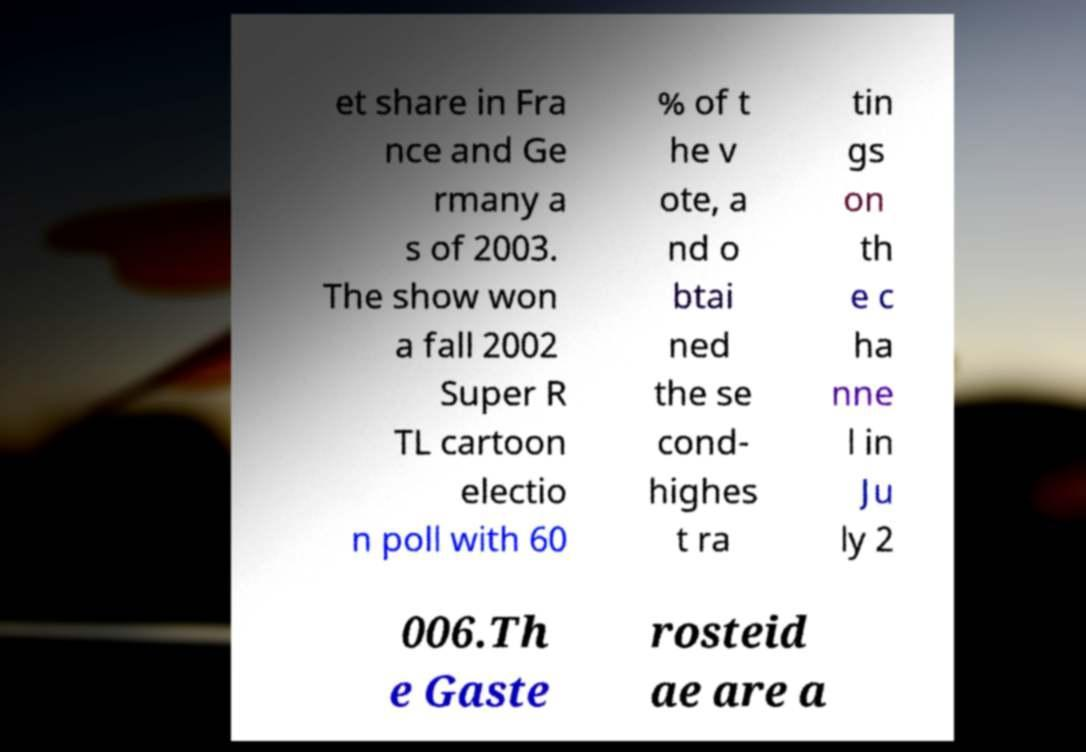Could you assist in decoding the text presented in this image and type it out clearly? et share in Fra nce and Ge rmany a s of 2003. The show won a fall 2002 Super R TL cartoon electio n poll with 60 % of t he v ote, a nd o btai ned the se cond- highes t ra tin gs on th e c ha nne l in Ju ly 2 006.Th e Gaste rosteid ae are a 